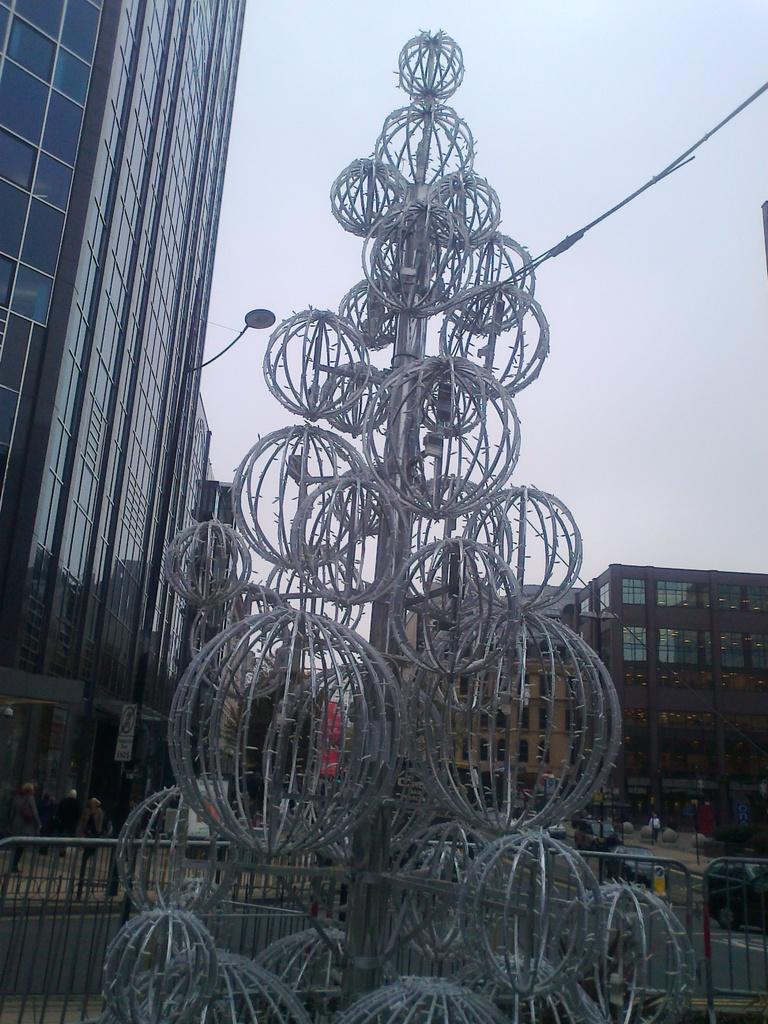What objects are in the middle of the image? There are iron frames in the shape of balls in the middle of the image. What can be seen in the background of the image? There are buildings in the background of the image. What is visible at the top of the image? The sky is visible at the top of the image. What type of trousers can be seen hanging from the iron frames in the image? There are no trousers present in the image; the iron frames are in the shape of balls. How many pages are visible in the image? There are no pages present in the image. 